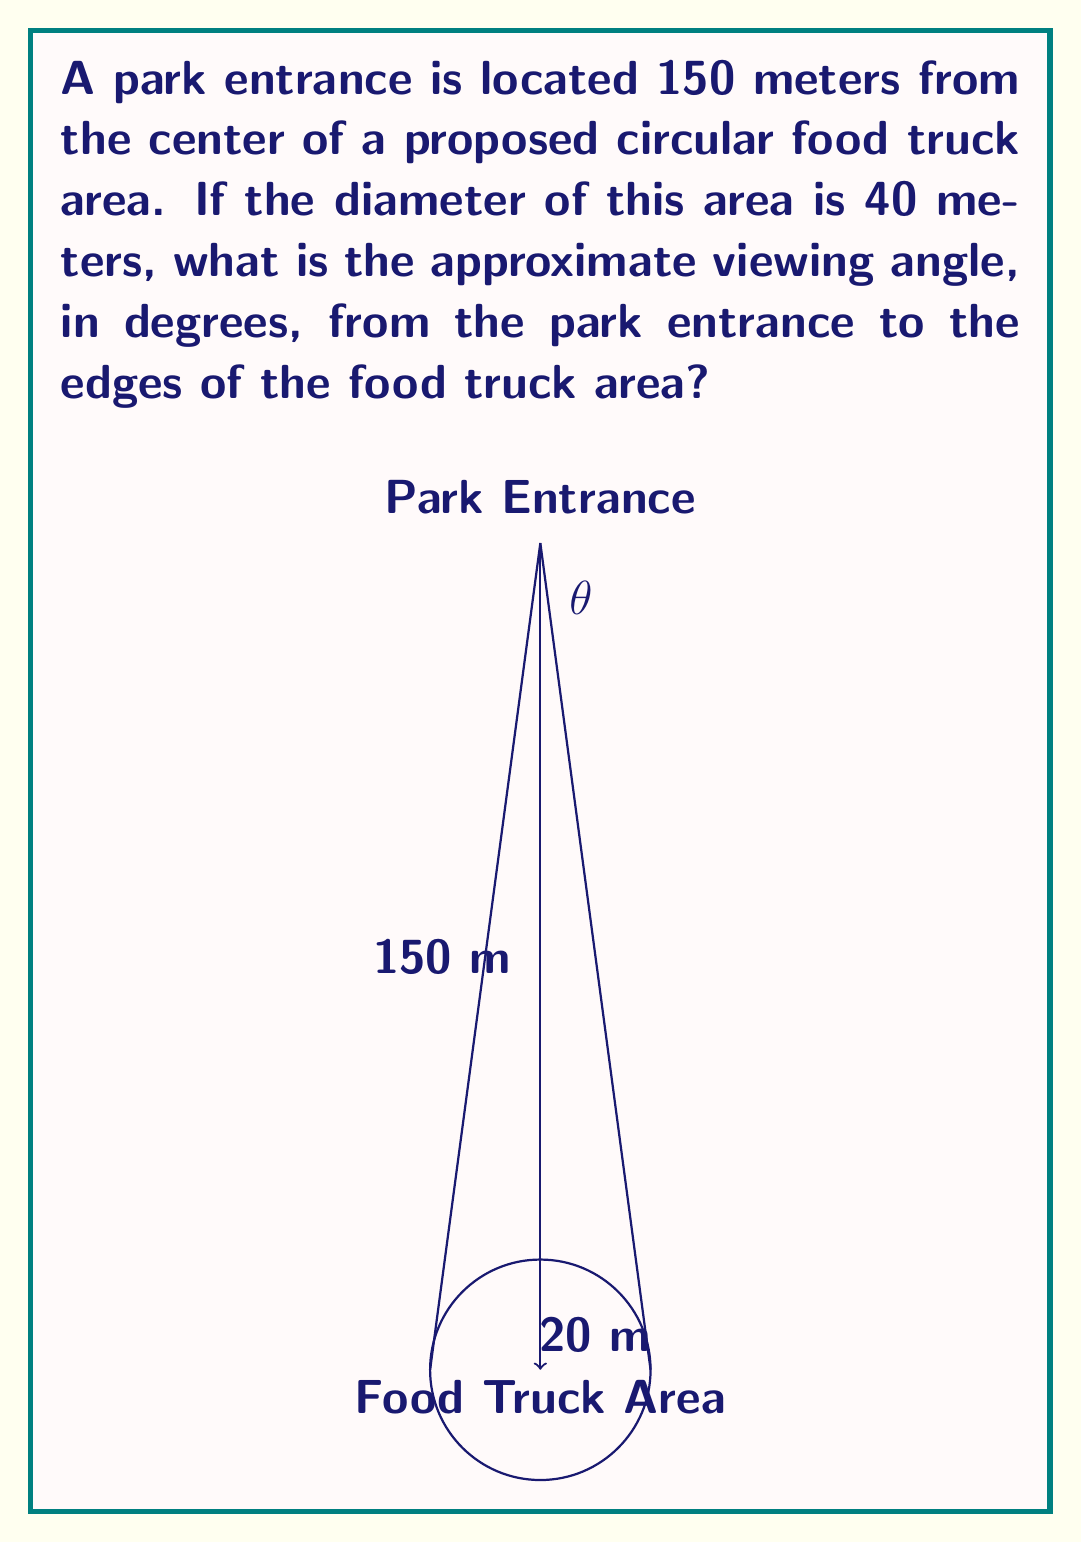Solve this math problem. Let's approach this step-by-step:

1) We can visualize this scenario as a right triangle where:
   - The hypotenuse is the line from the park entrance to the center of the food truck area (150 m)
   - The opposite side is the radius of the food truck area (half the diameter, so 20 m)

2) We need to find the angle $\theta$ at the park entrance. This angle is formed by the lines from the entrance to the edges of the food truck area.

3) We can use the inverse sine function (arcsin) to find half of this angle:

   $$\sin(\frac{\theta}{2}) = \frac{\text{opposite}}{\text{hypotenuse}} = \frac{20}{150}$$

4) Solving for $\frac{\theta}{2}$:

   $$\frac{\theta}{2} = \arcsin(\frac{20}{150})$$

5) Using a calculator or trigonometric tables:

   $$\frac{\theta}{2} \approx 7.66^\circ$$

6) To get the full viewing angle, we multiply this by 2:

   $$\theta \approx 7.66^\circ \times 2 = 15.32^\circ$$

7) Rounding to the nearest degree:

   $$\theta \approx 15^\circ$$
Answer: $15^\circ$ 